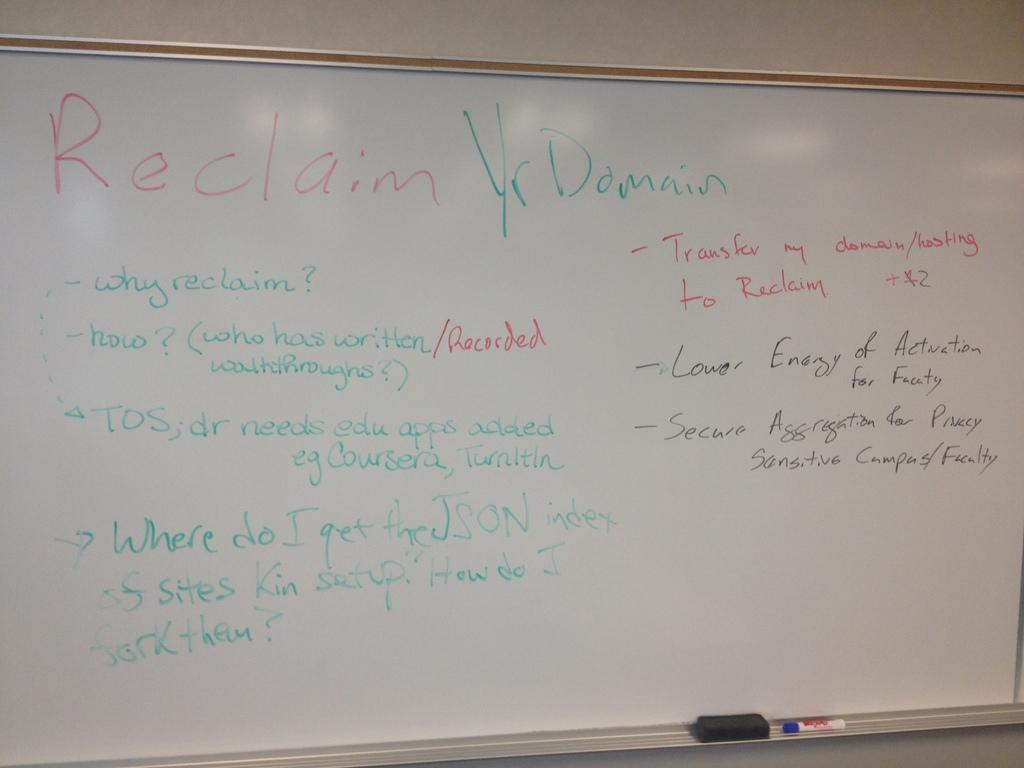Provide a one-sentence caption for the provided image. White board in a class room that talks about reclaim yr domain. 